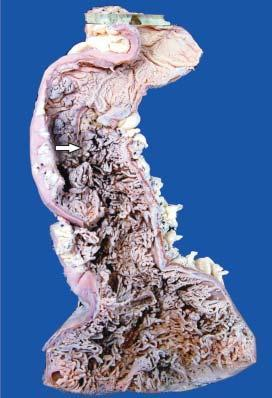s the necrosed area on right side of the field straddled with multiple polyoid structures of varying sizes many of which are pedunculated?
Answer the question using a single word or phrase. No 